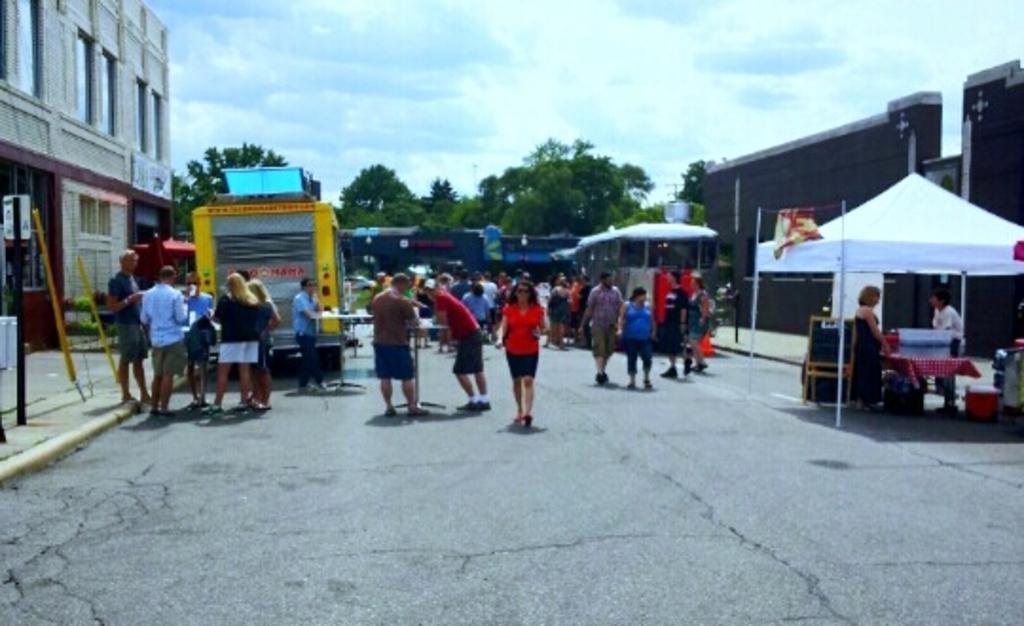In one or two sentences, can you explain what this image depicts? The picture is clicked outside a city. In the center of the picture, on the road there are people, tracks, tent, trees and other objects. On the left there are buildings, footpath and pole. On the right there are buildings, tent and people. 